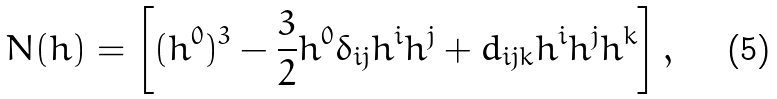Convert formula to latex. <formula><loc_0><loc_0><loc_500><loc_500>N ( h ) = \left [ ( h ^ { 0 } ) ^ { 3 } - \frac { 3 } { 2 } h ^ { 0 } \delta _ { i j } h ^ { i } h ^ { j } + d _ { i j k } h ^ { i } h ^ { j } h ^ { k } \right ] ,</formula> 